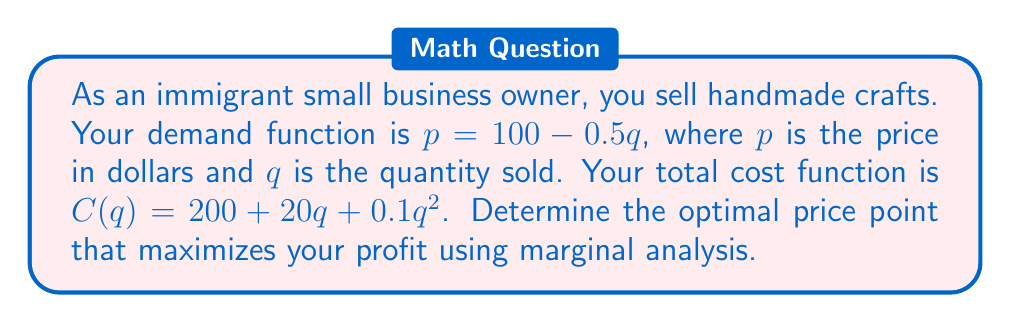Give your solution to this math problem. 1. First, we need to express the revenue function:
   $R(q) = pq = (100 - 0.5q)q = 100q - 0.5q^2$

2. The profit function is revenue minus cost:
   $P(q) = R(q) - C(q) = (100q - 0.5q^2) - (200 + 20q + 0.1q^2)$
   $P(q) = 100q - 0.5q^2 - 200 - 20q - 0.1q^2$
   $P(q) = 80q - 0.6q^2 - 200$

3. To maximize profit, we need to find where marginal profit (MP) equals zero:
   $MP = \frac{dP}{dq} = 80 - 1.2q$

4. Set MP to zero and solve for q:
   $80 - 1.2q = 0$
   $1.2q = 80$
   $q = \frac{80}{1.2} \approx 66.67$

5. Now that we have the optimal quantity, we can find the optimal price using the demand function:
   $p = 100 - 0.5q = 100 - 0.5(66.67) \approx 66.67$

6. Verify that this is a maximum by checking the second derivative:
   $\frac{d^2P}{dq^2} = -1.2 < 0$, confirming a maximum.
Answer: $66.67 